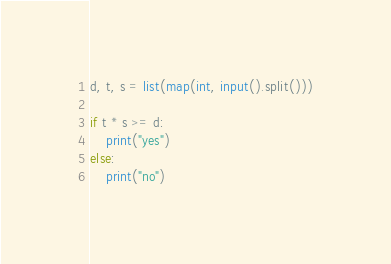<code> <loc_0><loc_0><loc_500><loc_500><_Python_>d, t, s = list(map(int, input().split()))

if t * s >= d:
    print("yes")
else:
    print("no")</code> 